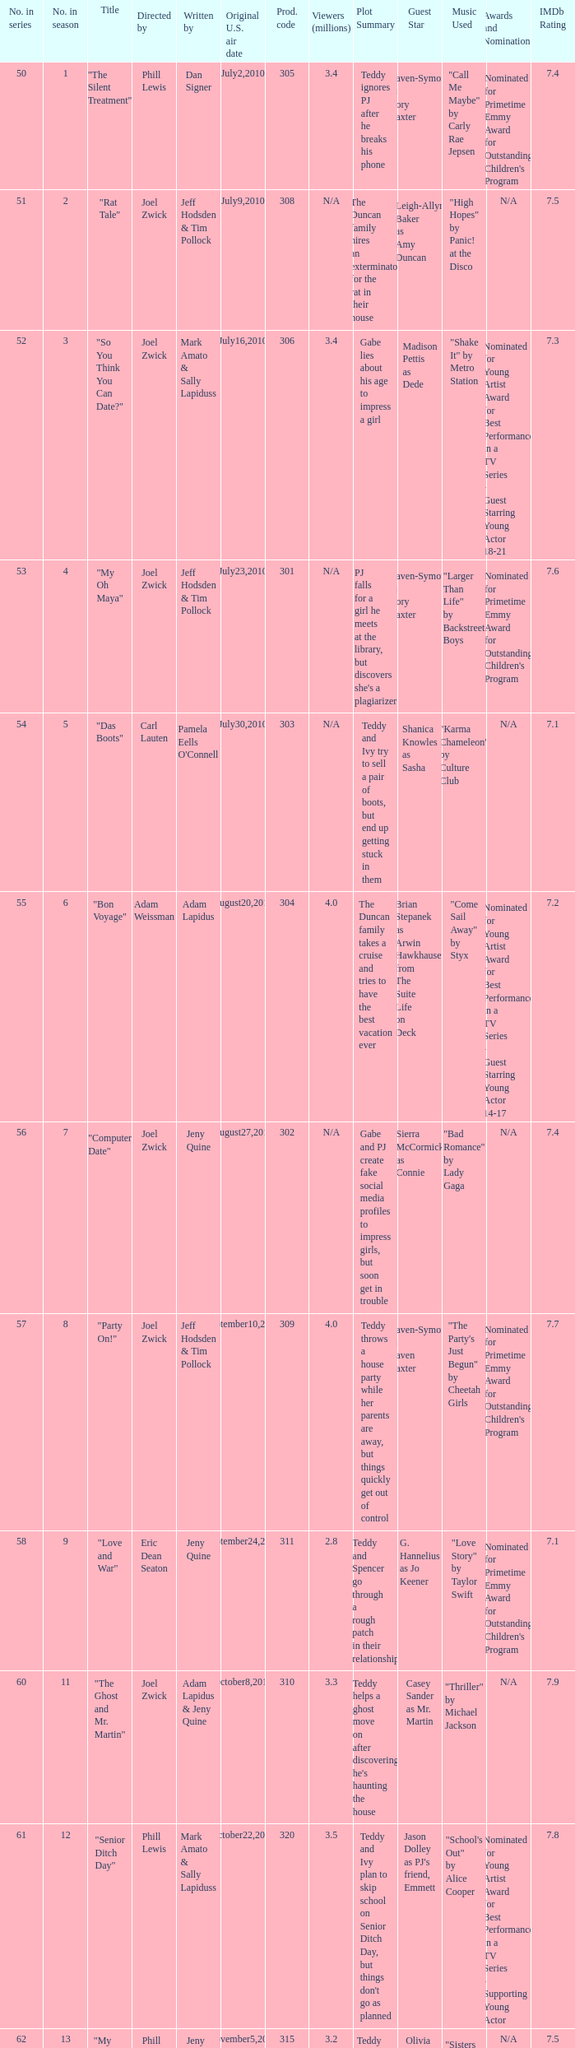On which us airing date were there January14,2011. 